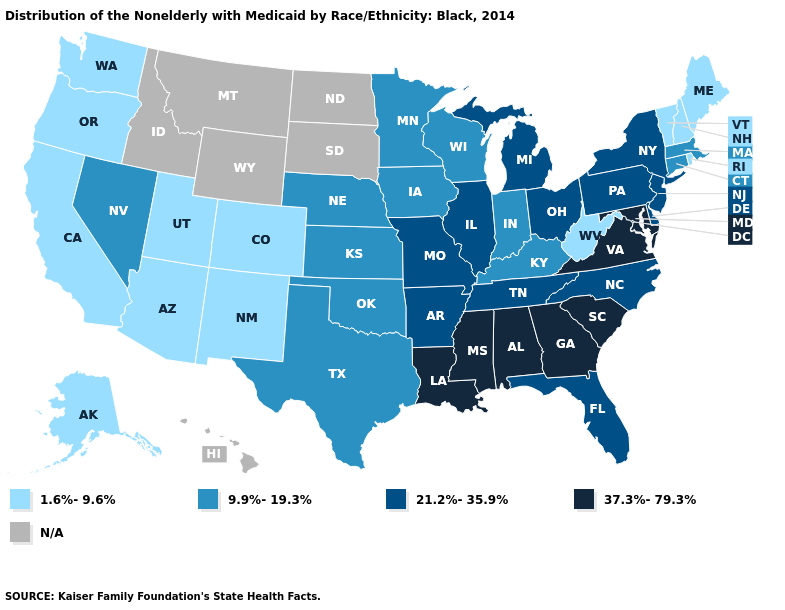What is the lowest value in states that border South Dakota?
Concise answer only. 9.9%-19.3%. What is the value of California?
Write a very short answer. 1.6%-9.6%. Name the states that have a value in the range N/A?
Give a very brief answer. Hawaii, Idaho, Montana, North Dakota, South Dakota, Wyoming. Name the states that have a value in the range 1.6%-9.6%?
Keep it brief. Alaska, Arizona, California, Colorado, Maine, New Hampshire, New Mexico, Oregon, Rhode Island, Utah, Vermont, Washington, West Virginia. Among the states that border North Dakota , which have the highest value?
Keep it brief. Minnesota. Name the states that have a value in the range 1.6%-9.6%?
Keep it brief. Alaska, Arizona, California, Colorado, Maine, New Hampshire, New Mexico, Oregon, Rhode Island, Utah, Vermont, Washington, West Virginia. What is the lowest value in the USA?
Quick response, please. 1.6%-9.6%. Does Ohio have the highest value in the MidWest?
Keep it brief. Yes. Is the legend a continuous bar?
Short answer required. No. Name the states that have a value in the range 21.2%-35.9%?
Write a very short answer. Arkansas, Delaware, Florida, Illinois, Michigan, Missouri, New Jersey, New York, North Carolina, Ohio, Pennsylvania, Tennessee. What is the lowest value in the South?
Be succinct. 1.6%-9.6%. Which states have the lowest value in the USA?
Write a very short answer. Alaska, Arizona, California, Colorado, Maine, New Hampshire, New Mexico, Oregon, Rhode Island, Utah, Vermont, Washington, West Virginia. Among the states that border Oregon , does Washington have the highest value?
Concise answer only. No. Does Pennsylvania have the highest value in the USA?
Keep it brief. No. 